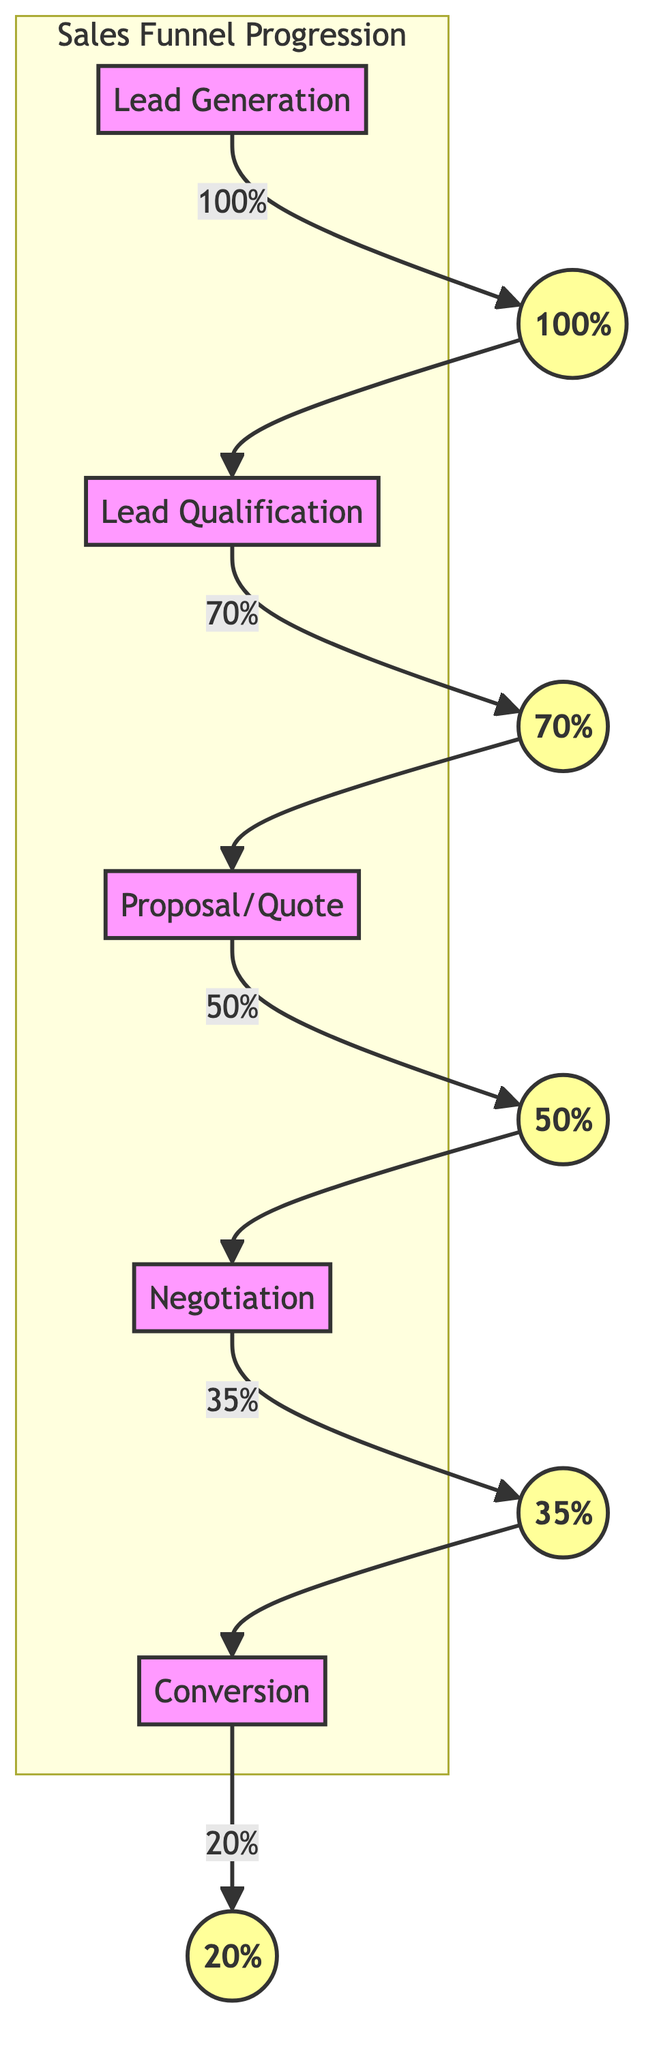What is the total percentage conversion from lead generation to conversion? The total percentage conversion from lead generation to conversion can be computed by multiplying the percentage conversions at each stage. Starting from 100% at Lead Generation, we multiply by 70% for Lead Qualification, then 50% for Proposal/Quote, followed by 35% for Negotiation, and finally 20% for Conversion. Thus, the calculation is 100% * 70% * 50% * 35% * 20% = 0.1, indicating that 10% of leads ultimately convert.
Answer: 10% Which stage has the highest percentage of leads? The stage with the highest percentage of leads is the Lead Generation stage, which starts with 100% of leads entering the funnel. This is the initial stage before any conversions are made.
Answer: 100% What percentage of leads move from Proposal/Quote to Negotiation? The percentage of leads moving from Proposal/Quote to Negotiation is indicated on the edge connecting those two nodes. The diagram shows that 50% of leads proceed from the Proposal/Quote stage to the Negotiation stage.
Answer: 50% How many total stages are represented in the sales funnel? To find the total stages represented in the sales funnel, we can count the nodes in the diagram. There are five stages: Lead Generation, Lead Qualification, Proposal/Quote, Negotiation, and Conversion.
Answer: 5 What is the percentage conversion from Negotiation to Conversion? The percentage conversion from Negotiation to Conversion is directly represented on the edge connecting these two stages. The diagram states that 35% of leads proceed from Negotiation to Conversion.
Answer: 35% What is the conversion percentage after the Lead Qualification stage? After the Lead Qualification stage, the conversion percentage drops to 70%. This value is shown directly connected to the Lead Qualification node in the diagram, indicating the rate at which leads qualify for the next stage.
Answer: 70% What is the relative position of the Proposal/Quote stage in the funnel? The Proposal/Quote stage is the third stage in the funnel, following Lead Qualification and preceding Negotiation. It can be identified by its position within the flow from top to bottom, signifying its order in the sales process.
Answer: Third Which stage experiences the smallest percentage conversion? The smallest percentage conversion is at the Conversion stage, where only 20% of leads are converted. This is explicitly mentioned in the diagram and is the final conversion rate in the funnel.
Answer: 20% 